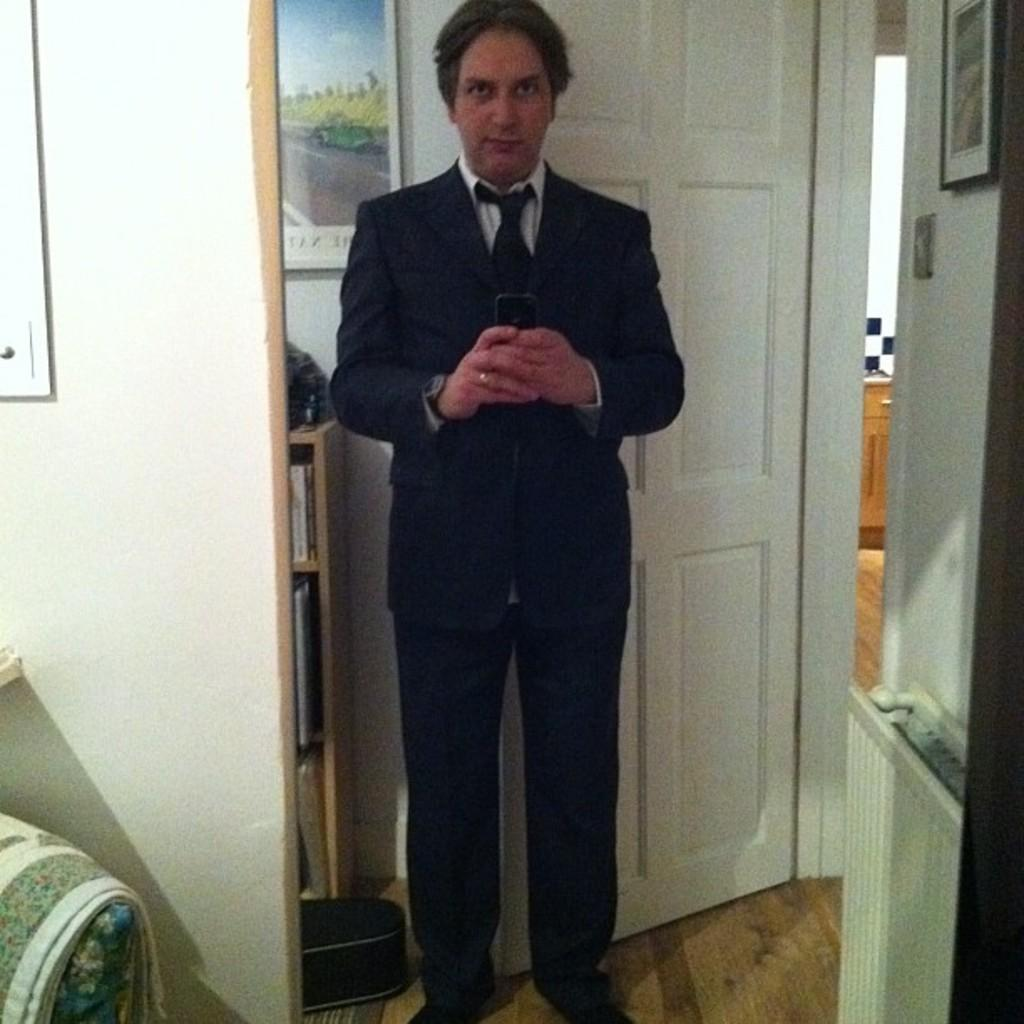What is the man in the image doing? The man is standing in the image and holding a mobile in his hands. What can be seen on the wall in the image? There are photo frames on the wall. What is the man wearing in the image? The man is wearing a coat and tie. What architectural feature is present in the image? There is a door in the image. What piece of furniture can be seen in the image? There is a bookshelf in the image. Are there any cobwebs visible in the image? There is no mention of cobwebs in the provided facts, so we cannot determine if any are present in the image. What type of rail is the man leaning on in the image? There is no rail present in the image; the man is standing and holding a mobile. 